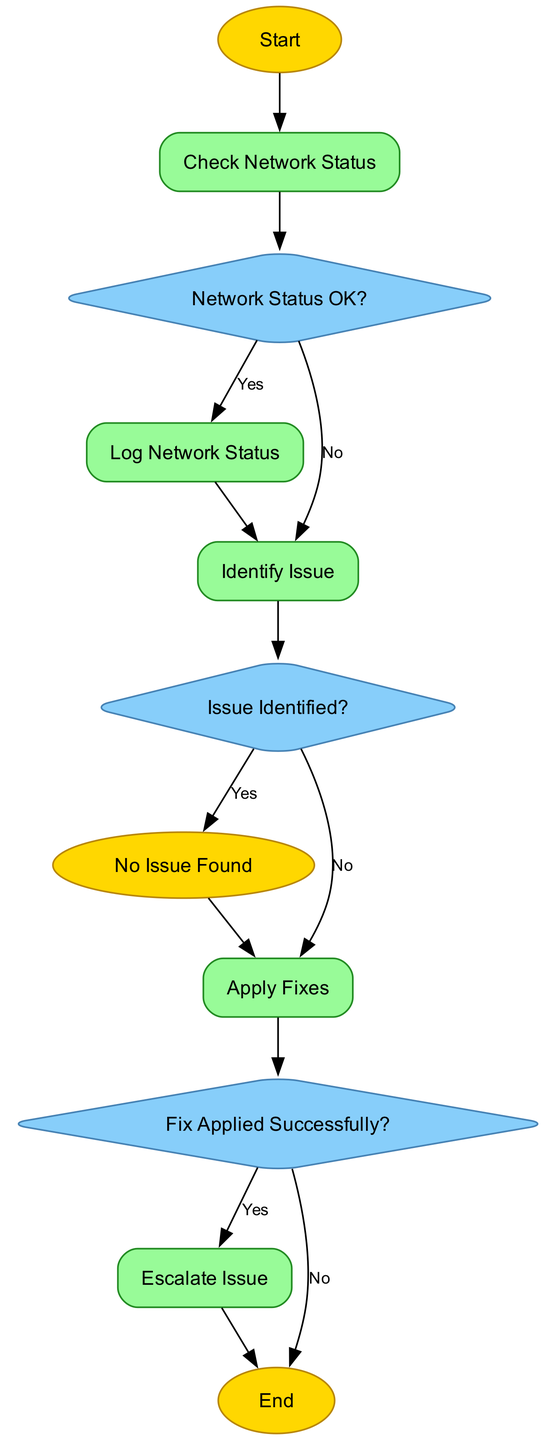What is the first node in the diagram? The first node is labeled "Start" which indicates the beginning of the automated process for detecting and fixing network issues.
Answer: Start How many decision nodes are present in the flowchart? There are three decision nodes: "Network Status OK?", "Issue Identified?", and "Fix Applied Successfully?".
Answer: 3 What happens if the network status is OK? If the network status is OK, the flow proceeds to log the network status, meaning the process does not identify any issues.
Answer: Log Network Status What follows after identifying a network issue? After identifying a network issue, the next step is to "Apply Fixes" using automatic scripts to resolve the problem.
Answer: Apply Fixes What is the last node in the process? The last node in the process is labeled "End", which signifies the conclusion of the flow once the issue is fixed or escalated.
Answer: End What action is taken if a fix is not applied successfully? If the fix is not applied successfully, the action taken is to "Escalate Issue" to a human network administrator for further assistance.
Answer: Escalate Issue How many processes are outlined in the flowchart? The processes in the flowchart include: "Check Network Status," "Log Network Status," "Identify Issue," "Apply Fixes," and "Escalate Issue," totaling five.
Answer: 5 What decision comes after applying fixes? The decision that follows after applying fixes is "Fix Applied Successfully?", where it checks the success of the fixes made.
Answer: Fix Applied Successfully? What is the outcome of the flow if no issue is found during the check? If no issue is found during the check, the outcome is that the process ends at "No Issue Found" without any further actions required.
Answer: No Issue Found 